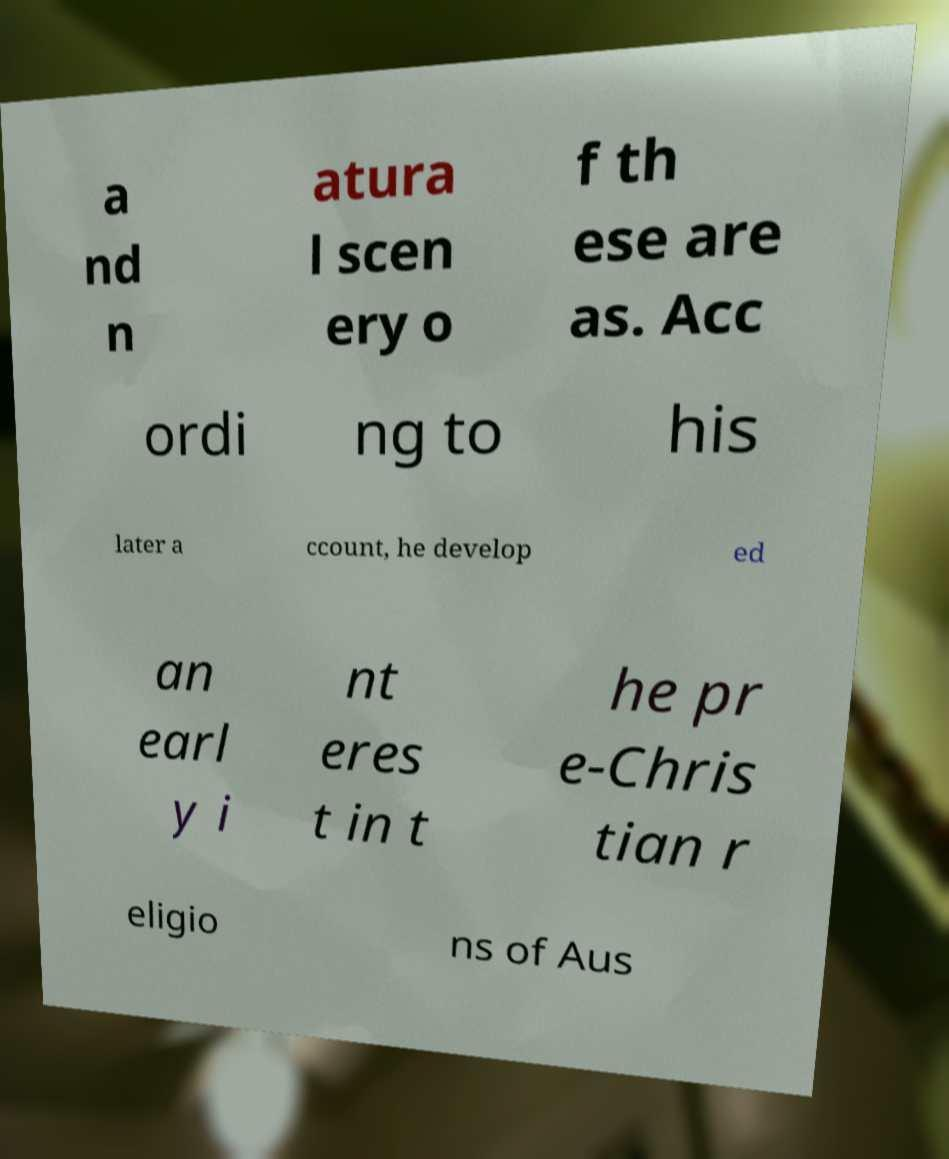Please identify and transcribe the text found in this image. a nd n atura l scen ery o f th ese are as. Acc ordi ng to his later a ccount, he develop ed an earl y i nt eres t in t he pr e-Chris tian r eligio ns of Aus 